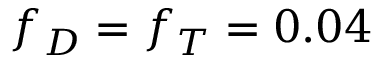Convert formula to latex. <formula><loc_0><loc_0><loc_500><loc_500>f _ { D } = f _ { T } = 0 . 0 4</formula> 